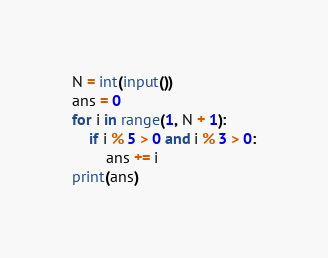<code> <loc_0><loc_0><loc_500><loc_500><_Python_>N = int(input())
ans = 0
for i in range(1, N + 1):
    if i % 5 > 0 and i % 3 > 0:
        ans += i
print(ans)
</code> 